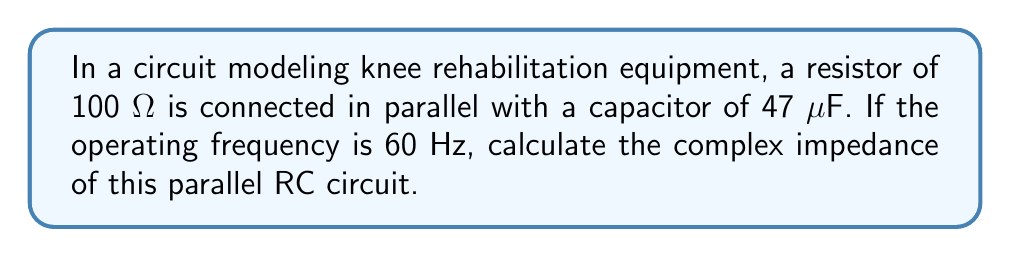Can you solve this math problem? Let's approach this step-by-step:

1) First, we need to calculate the reactance of the capacitor. The formula for capacitive reactance is:

   $X_C = \frac{1}{2\pi fC}$

   where $f$ is the frequency in Hz and $C$ is the capacitance in Farads.

2) Let's substitute our values:
   
   $X_C = \frac{1}{2\pi \cdot 60 \cdot 47 \times 10^{-6}} \approx 56.5 \, \Omega$

3) The impedance of a capacitor is purely imaginary and negative:

   $Z_C = -j56.5 \, \Omega$

4) For a parallel RC circuit, we use the formula:

   $\frac{1}{Z} = \frac{1}{R} + \frac{1}{Z_C}$

5) Substituting our values:

   $\frac{1}{Z} = \frac{1}{100} + \frac{1}{-j56.5}$

6) To add these fractions, we need to rationalize the complex denominator:

   $\frac{1}{Z} = \frac{1}{100} + \frac{j56.5}{(-j56.5)(j56.5)} = \frac{1}{100} + \frac{j56.5}{3192.25}$

7) Now we can add the fractions:

   $\frac{1}{Z} = \frac{0.01 + j0.0177}{1}$

8) To get Z, we need to take the reciprocal:

   $Z = \frac{1}{0.01 + j0.0177} = \frac{0.01 - j0.0177}{(0.01)^2 + (0.0177)^2} \approx 44.96 - j79.56$

9) This can be written in polar form as:

   $Z \approx 91.45 \angle -60.5°\, \Omega$
Answer: $Z \approx 91.45 \angle -60.5°\, \Omega$ or $Z \approx 44.96 - j79.56\, \Omega$ 